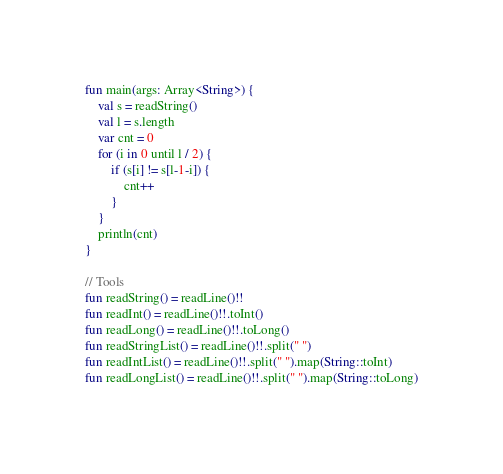Convert code to text. <code><loc_0><loc_0><loc_500><loc_500><_Kotlin_>fun main(args: Array<String>) {
    val s = readString()
    val l = s.length
    var cnt = 0
    for (i in 0 until l / 2) {
        if (s[i] != s[l-1-i]) {
            cnt++
        }
    }
    println(cnt)
}

// Tools
fun readString() = readLine()!!
fun readInt() = readLine()!!.toInt()
fun readLong() = readLine()!!.toLong()
fun readStringList() = readLine()!!.split(" ")
fun readIntList() = readLine()!!.split(" ").map(String::toInt)
fun readLongList() = readLine()!!.split(" ").map(String::toLong)</code> 